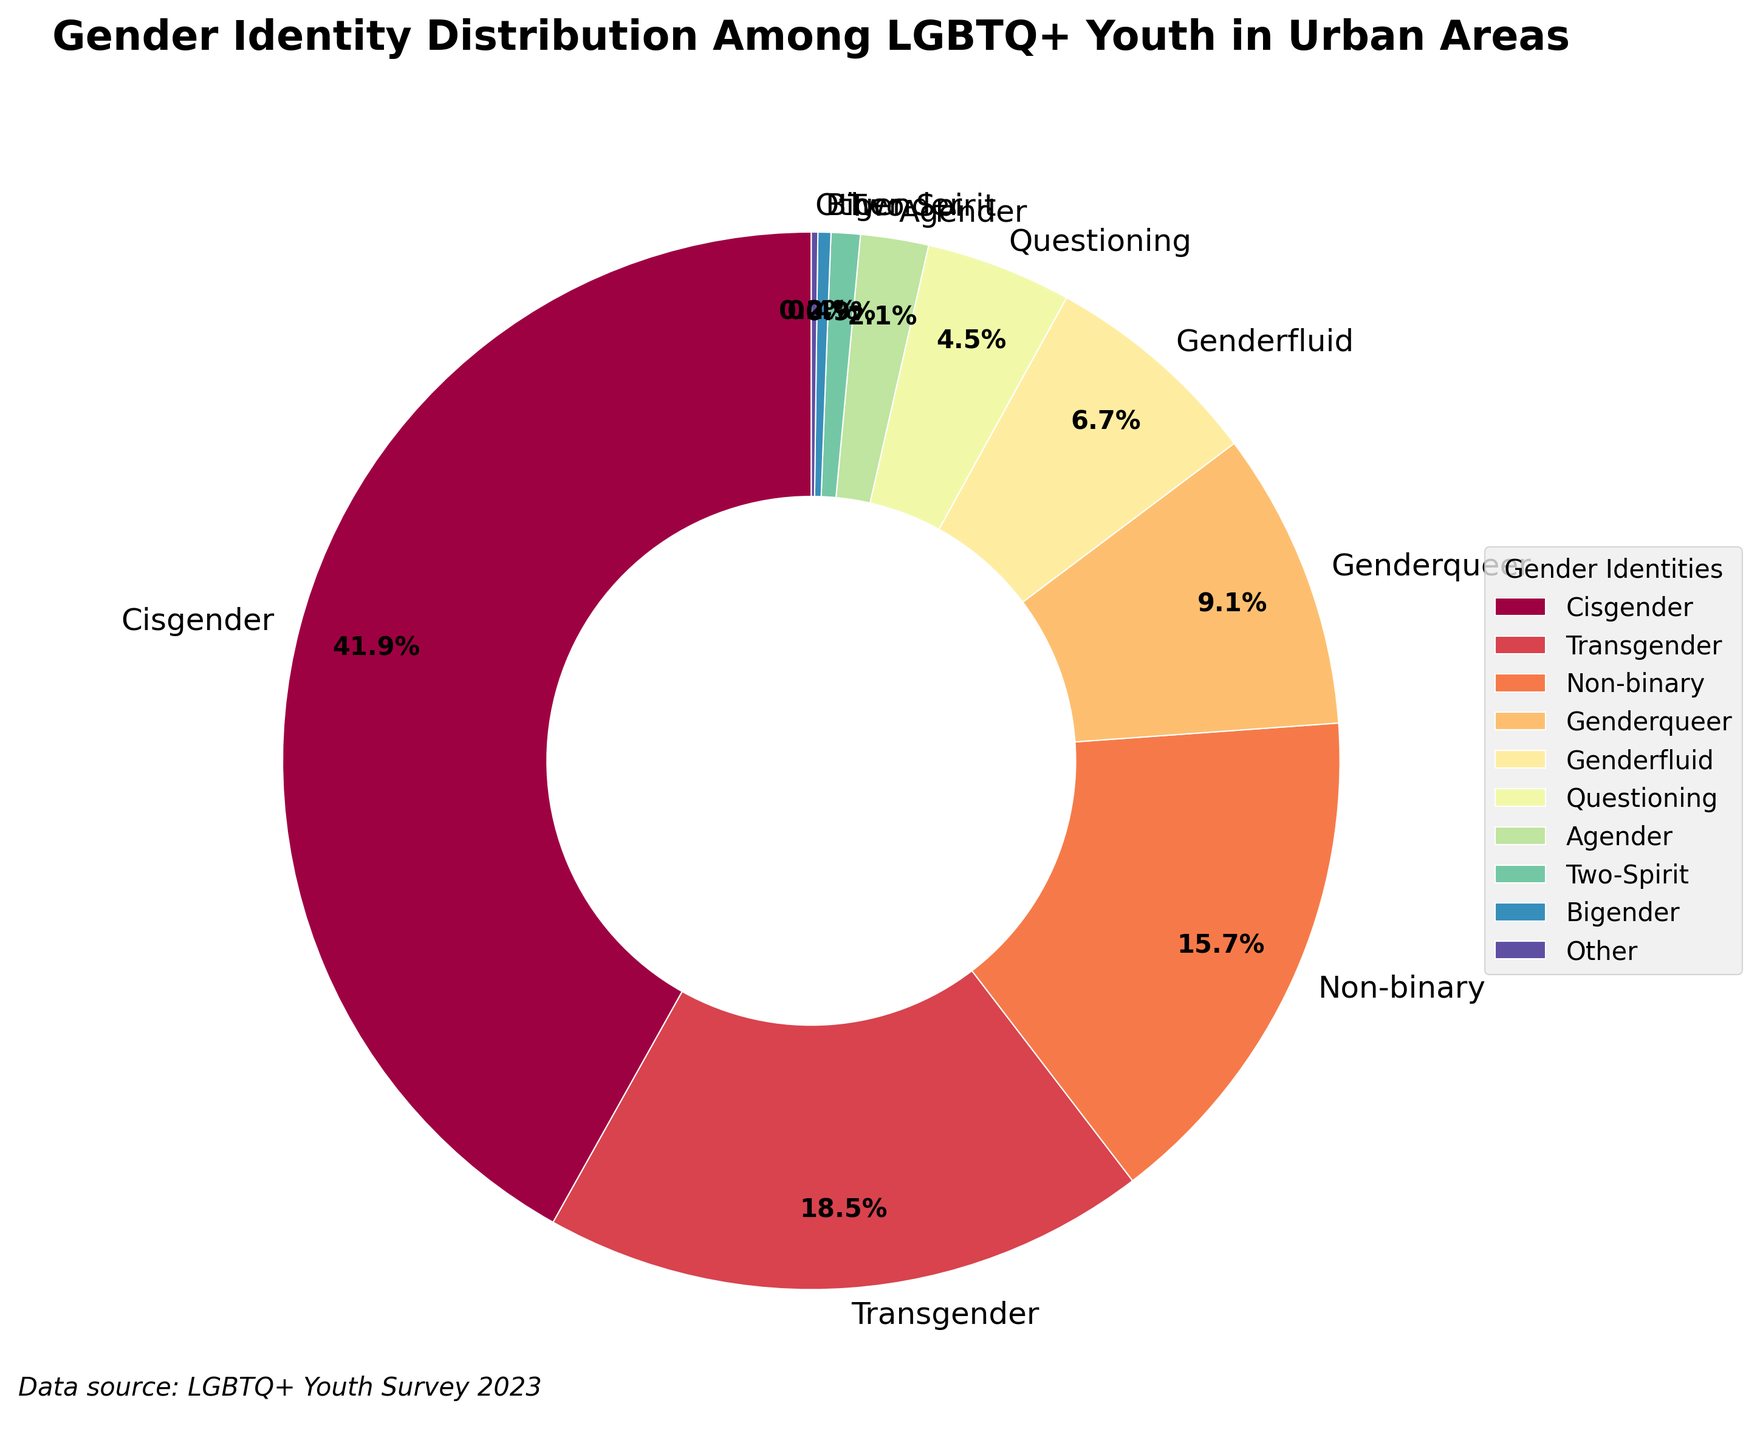What percentage of LGBTQ+ youth in urban areas identify as Cisgender or Transgender combined? To find the combined percentage of Cisgender and Transgender youth, add their individual percentages: 42.3% (Cisgender) + 18.7% (Transgender) = 61%
Answer: 61% Which gender identity has a lower percentage, Genderqueer or Genderfluid? Compare the percentages of Genderqueer (9.2%) and Genderfluid (6.8%) visually in the figure. Genderfluid has the lower percentage.
Answer: Genderfluid What is the total percentage of LGBTQ+ youth in urban areas who identify as Non-binary, Questioning, and Agender? Sum up the percentages of Non-binary, Questioning, and Agender: 15.9% (Non-binary) + 4.5% (Questioning) + 2.1% (Agender) = 22.5%
Answer: 22.5% Are there more youth identifying as Two-Spirit, Bigender, or Other compared to Agender? Compare the combined percentage of Two-Spirit (0.9%), Bigender (0.4%), and Other (0.2%) to Agender (2.1%). Adding the percentages of Two-Spirit, Bigender, and Other: 0.9% + 0.4% + 0.2% = 1.5%, which is less than 2.1%.
Answer: No What is the difference in percentage between the gender identity with the highest and lowest representation? Subtract the percentage of the smallest group (Other, 0.2%) from the largest group (Cisgender, 42.3%): 42.3% - 0.2% = 42.1%
Answer: 42.1% How does the percentage of Non-binary youth compare to that of Genderqueer youth? The percentage of Non-binary youth (15.9%) is higher than that of Genderqueer youth (9.2%).
Answer: Non-binary (15.9%) is higher Which gender identity has a percentage closest to 10% and what is that percentage? Identify the percentage closest to 10% from the figure. Genderqueer is the closest with 9.2%.
Answer: Genderqueer, 9.2% What fraction of the surveyed population identifies as Genderfluid? The percentage of Genderfluid is 6.8%. To convert this to a fraction: 6.8% = 6.8/100 = 68/1000 = 17/250.
Answer: 17/250 